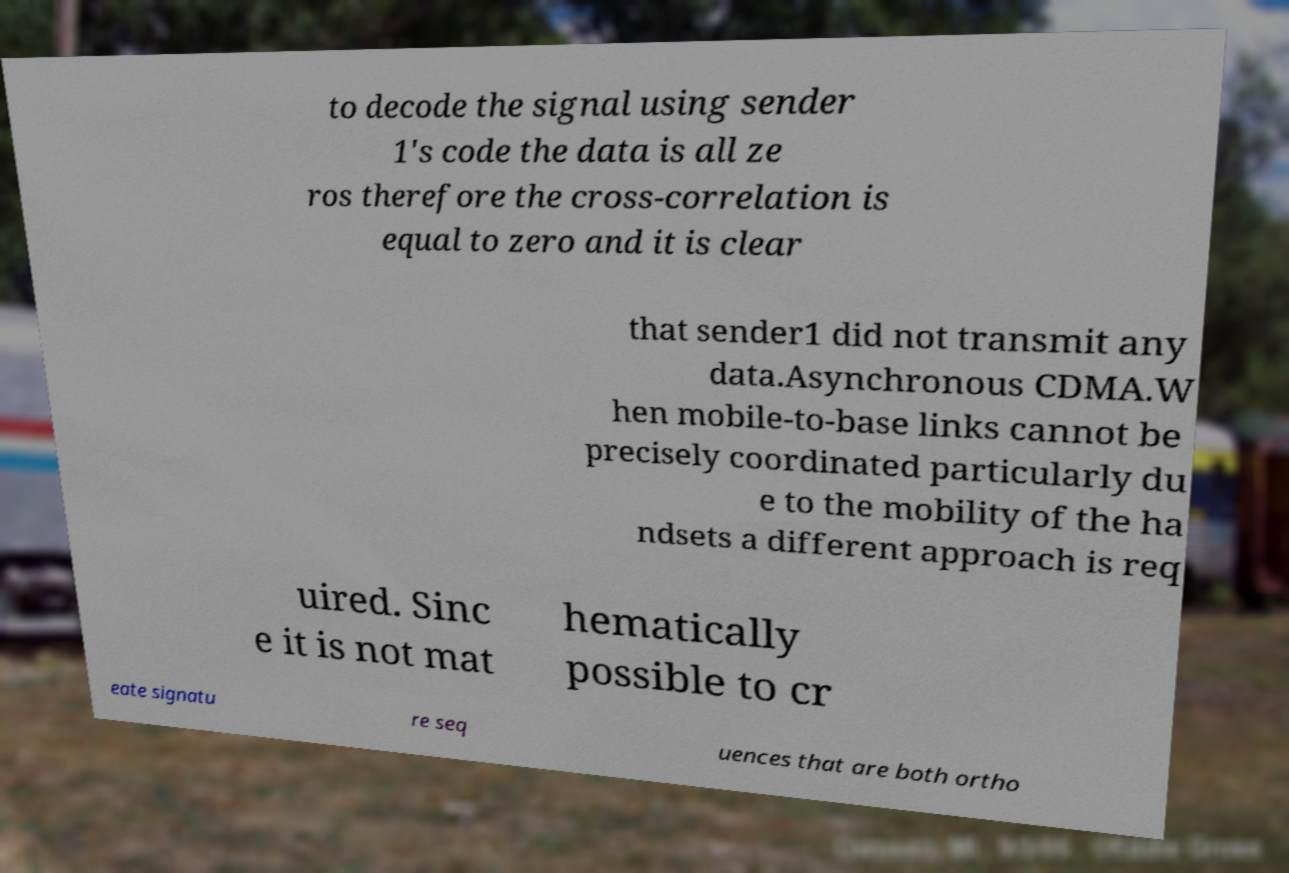I need the written content from this picture converted into text. Can you do that? to decode the signal using sender 1's code the data is all ze ros therefore the cross-correlation is equal to zero and it is clear that sender1 did not transmit any data.Asynchronous CDMA.W hen mobile-to-base links cannot be precisely coordinated particularly du e to the mobility of the ha ndsets a different approach is req uired. Sinc e it is not mat hematically possible to cr eate signatu re seq uences that are both ortho 